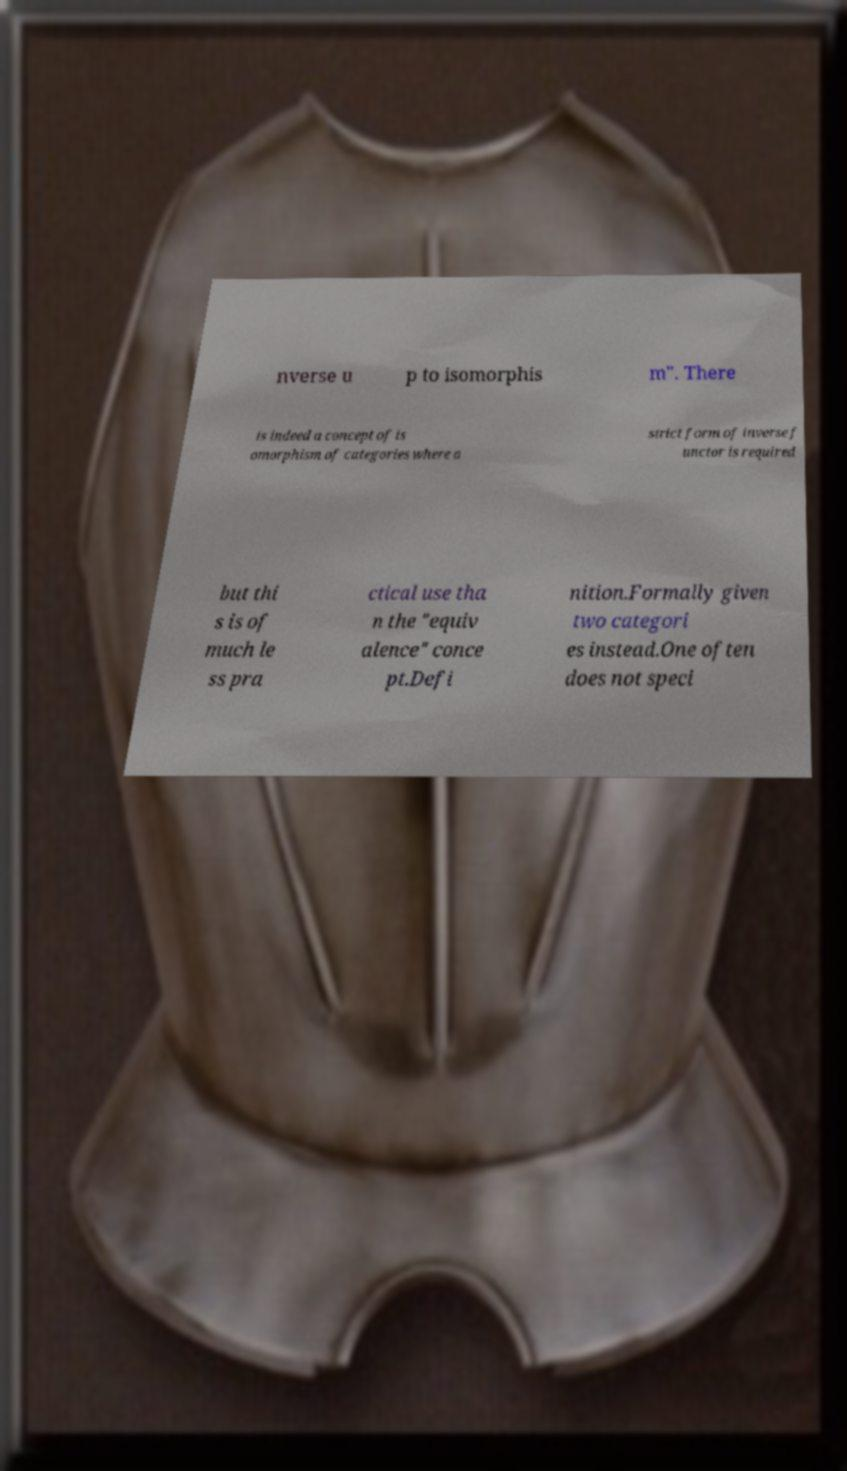Could you extract and type out the text from this image? nverse u p to isomorphis m". There is indeed a concept of is omorphism of categories where a strict form of inverse f unctor is required but thi s is of much le ss pra ctical use tha n the "equiv alence" conce pt.Defi nition.Formally given two categori es instead.One often does not speci 